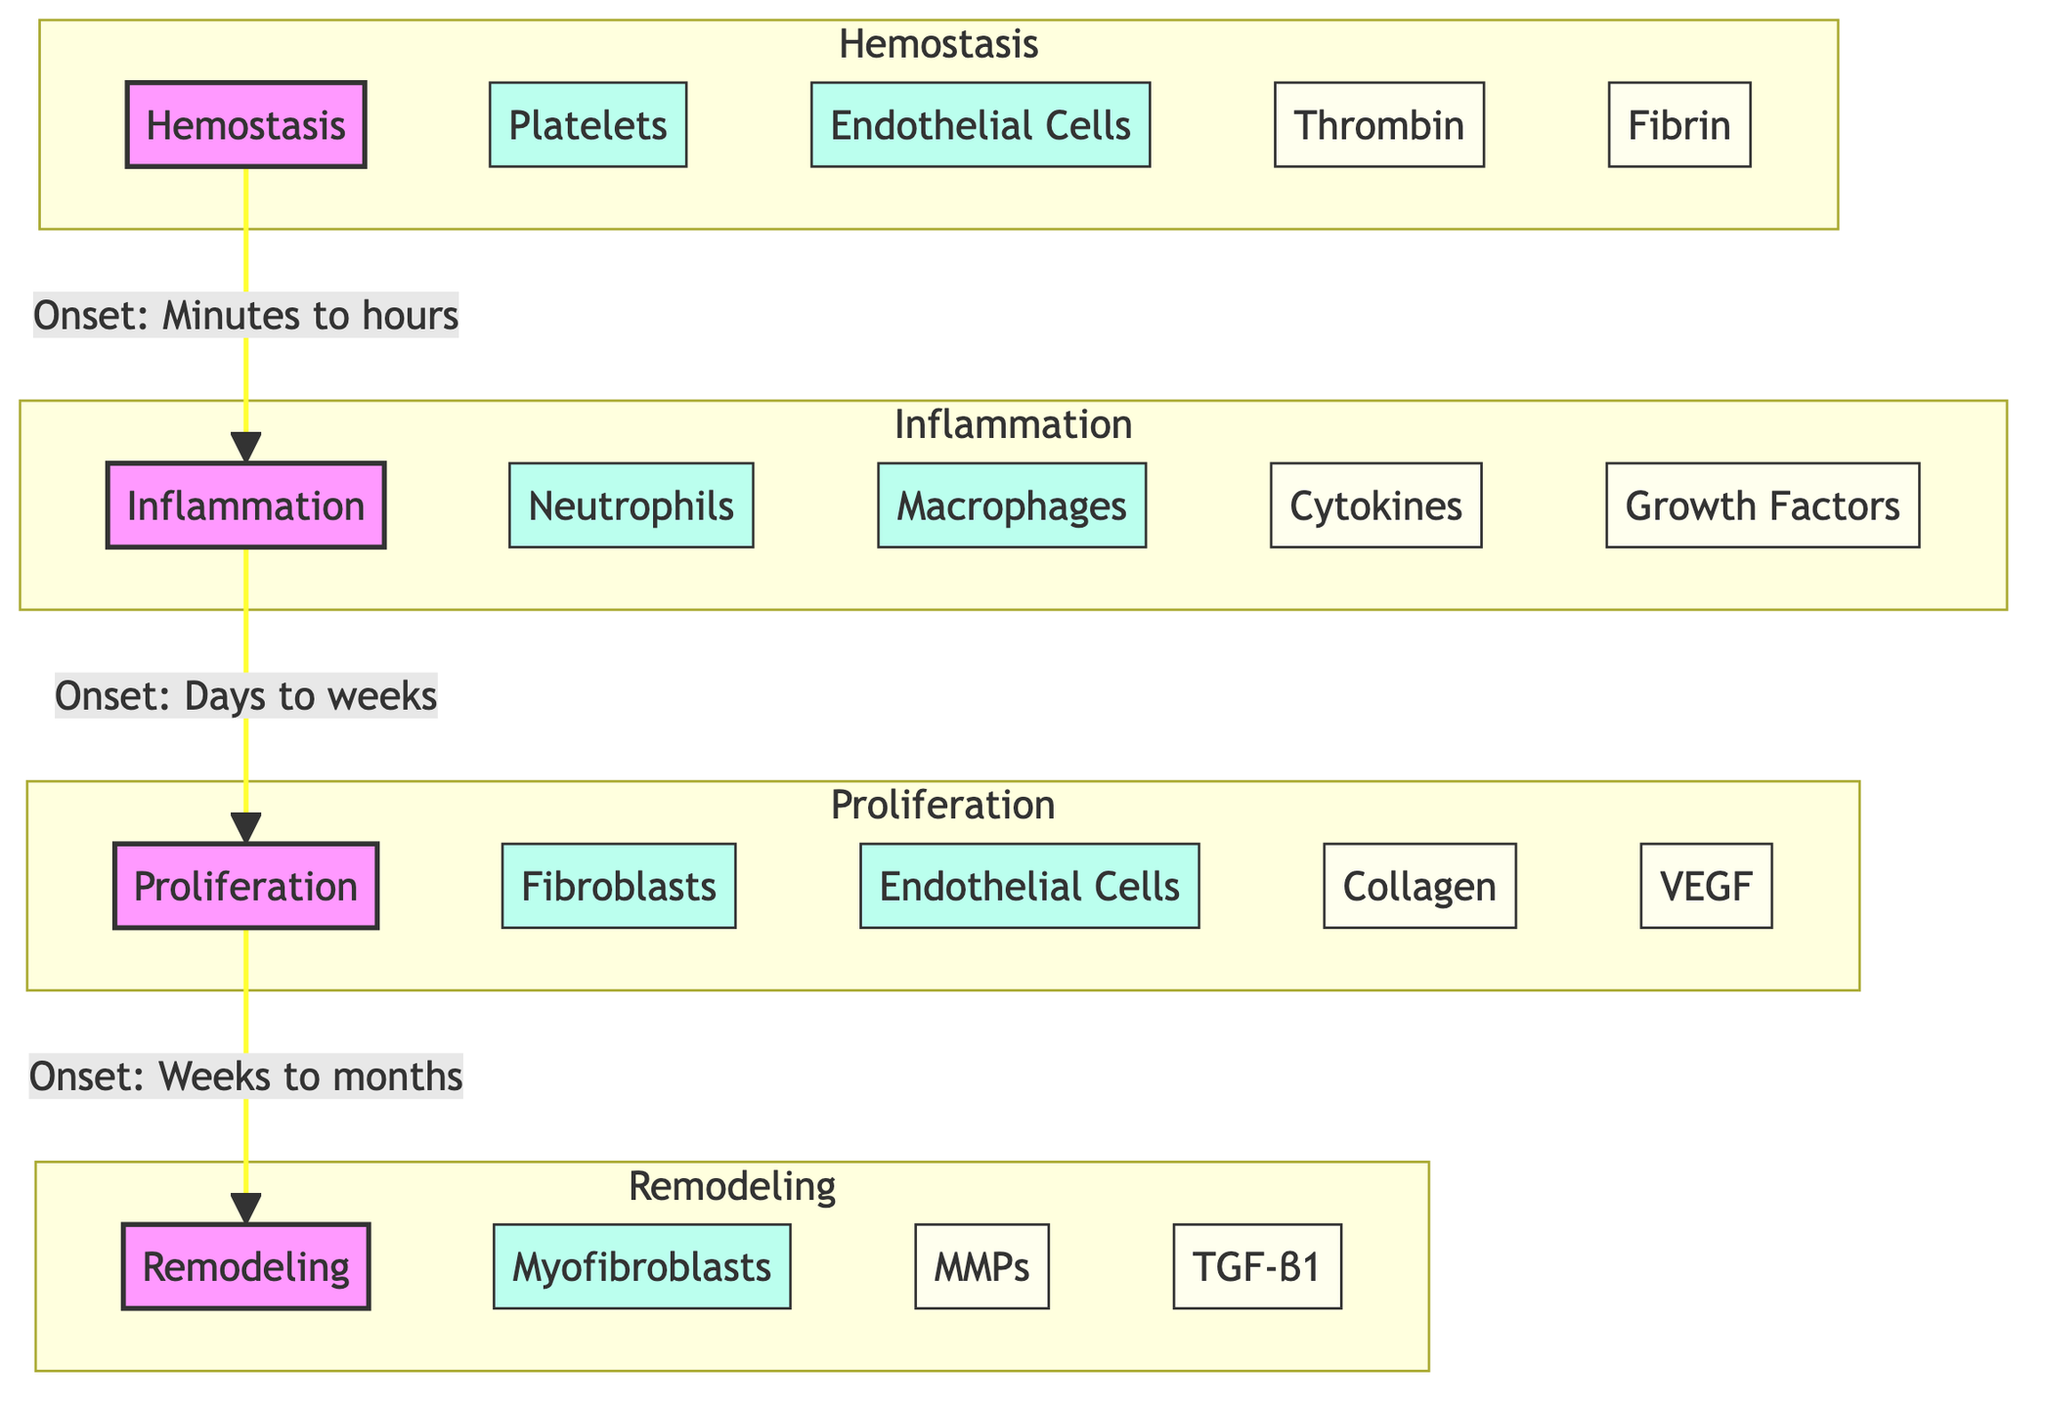What is the initial phase of wound healing? The diagram clearly labels the first phase as "Hemostasis," indicating it is the initial stage in the wound healing process.
Answer: Hemostasis How many cell types are involved in the Inflammation phase? By looking at the subgroup "Inflammation," it is evident that there are two cell types labeled: "Neutrophils" and "Macrophages." This sums up to two cell types in this phase.
Answer: 2 What is the onset duration for the Proliferation phase? The diagram specifies that the onset for the Proliferation phase is "Weeks to months," making this the correct duration.
Answer: Weeks to months Which growth factor is associated with Proliferation? Within the Proliferation phase, the diagram includes "VEGF" as a growth factor tied to this stage. Therefore, this is the correct answer.
Answer: VEGF What connects Inflammation to Proliferation? The diagram illustrates that the connection between Inflammation and Proliferation is indicated by the flow from "I" to "P." While there is no specific term to describe the connection, the relationship is established through the sequential flow from one phase to another.
Answer: I to P Which cell type is associated with the Remodeling phase? Looking at the Remodeling phase, "Myofibroblasts" is listed as a specific cell type within this stage. This is the only cell type mentioned here.
Answer: Myofibroblasts What is the main molecular component involved in Hemostasis? The diagram highlights "Thrombin" and "Fibrin" as molecular components in Hemostasis, but the first and more critical one is "Thrombin".
Answer: Thrombin What is the order of phases in the wound healing process? The diagram shows a clear sequence from Hemostasis to Inflammation, followed by Proliferation, and lastly Remodeling. This establishes the chronological order of the phases.
Answer: Hemostasis, Inflammation, Proliferation, Remodeling 